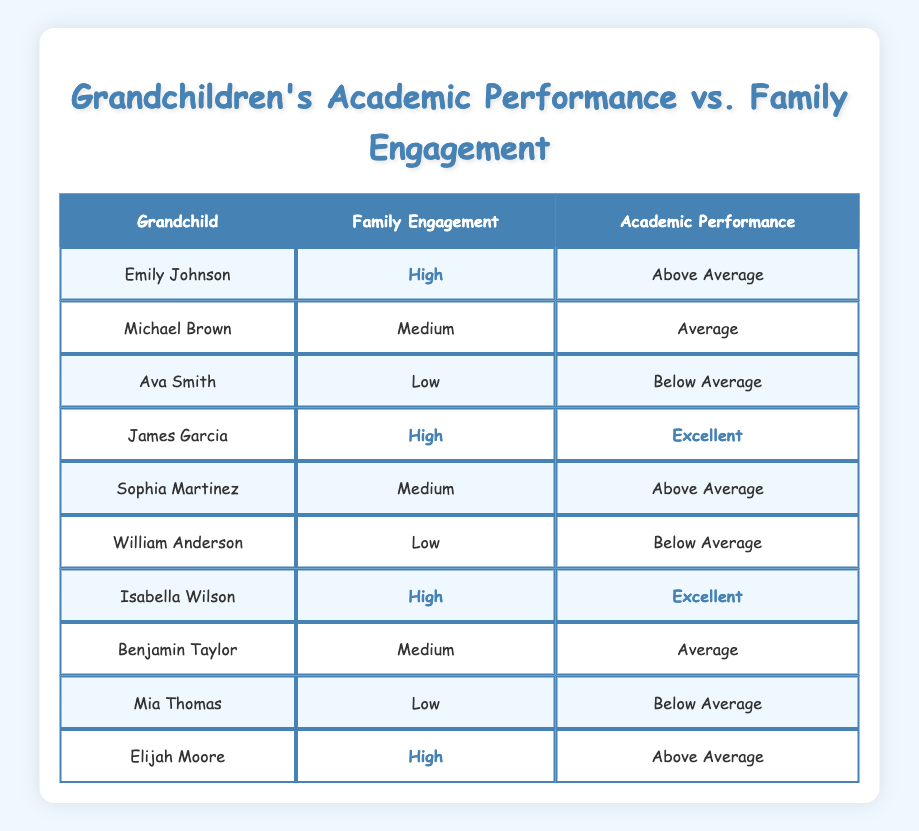What family engagement level does James Garcia have? James Garcia's row in the table clearly indicates that his family engagement level is classified as "High."
Answer: High How many grandchildren have a low family engagement level? By reviewing the table, I can see that there are three grandchildren listed with a "Low" family engagement level (Ava Smith, William Anderson, and Mia Thomas).
Answer: 3 Is it true that all grandchildren with high family engagement levels have above-average academic performance? Looking closely at the table, I can see that James Garcia and Isabella Wilson, both with high engagement levels, have "Excellent" performance, while Emily Johnson and Elijah Moore have "Above Average" performance. Thus, all high engagement grandchildren have at least above-average performance, confirming the statement is true.
Answer: Yes What is the academic performance of grandchildren who have a medium family engagement level? The table shows that Michael Brown and Benjamin Taylor, both with a "Medium" family engagement level, have "Average" performance and "Average" performance respectively, indicating that both have the same performance rating.
Answer: Average Which family engagement level corresponds to the highest number of "Below Average" performances? Upon examination of the table, only the grandchildren with a "Low" family engagement level (Ava Smith, William Anderson, and Mia Thomas) have "Below Average" performance, indicating that this level correlates with the highest number of below-average performances (3).
Answer: Low What percentage of grandchildren with high family engagement have excellent academic performance? In the table, there are 4 grandchildren with high engagement levels (James Garcia, Isabella Wilson, Emily Johnson, and Elijah Moore). Out of these, 2 have excellent performance (James Garcia and Isabella Wilson). Calculating the percentage gives (2/4) * 100 = 50%.
Answer: 50% How does the average academic performance of those with low family engagement compare to those with high family engagement? For the low family engagement group (Ava Smith, William Anderson, and Mia Thomas), the performances are "Below Average" for all three. For the high engagement group (Emily Johnson, James Garcia, Isabella Wilson, and Elijah Moore), the performances are "Above Average" and "Excellent." There are 3 low performers versus 4 high performers, but the high group shows overall better performance. This indicates that high engagement leads to comparatively much better performances than low engagement.
Answer: High engagement outperforms low engagement What is the total number of "Above Average" performances among grandchildren? In the table, the children who received "Above Average" ratings are Emily Johnson, Elijah Moore, and Sophia Martinez, making a total of three such performances.
Answer: 3 